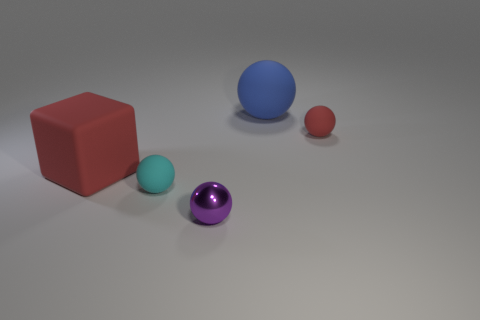Subtract all tiny cyan spheres. How many spheres are left? 3 Subtract all red spheres. How many spheres are left? 3 Subtract 1 spheres. How many spheres are left? 3 Add 4 small brown matte cubes. How many objects exist? 9 Subtract 1 red blocks. How many objects are left? 4 Subtract all blocks. How many objects are left? 4 Subtract all blue balls. Subtract all green cylinders. How many balls are left? 3 Subtract all yellow cubes. How many gray spheres are left? 0 Subtract all tiny yellow shiny cylinders. Subtract all tiny red matte things. How many objects are left? 4 Add 4 tiny cyan matte spheres. How many tiny cyan matte spheres are left? 5 